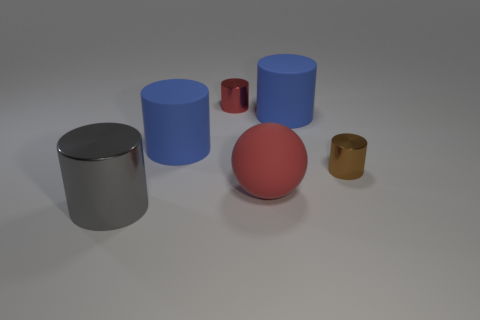Subtract 2 cylinders. How many cylinders are left? 3 Subtract all big gray cylinders. How many cylinders are left? 4 Subtract all brown cylinders. How many cylinders are left? 4 Subtract all green cylinders. Subtract all blue blocks. How many cylinders are left? 5 Add 1 large gray shiny cylinders. How many objects exist? 7 Subtract all balls. How many objects are left? 5 Add 1 big red objects. How many big red objects exist? 2 Subtract 1 red cylinders. How many objects are left? 5 Subtract all spheres. Subtract all big blue cylinders. How many objects are left? 3 Add 2 large balls. How many large balls are left? 3 